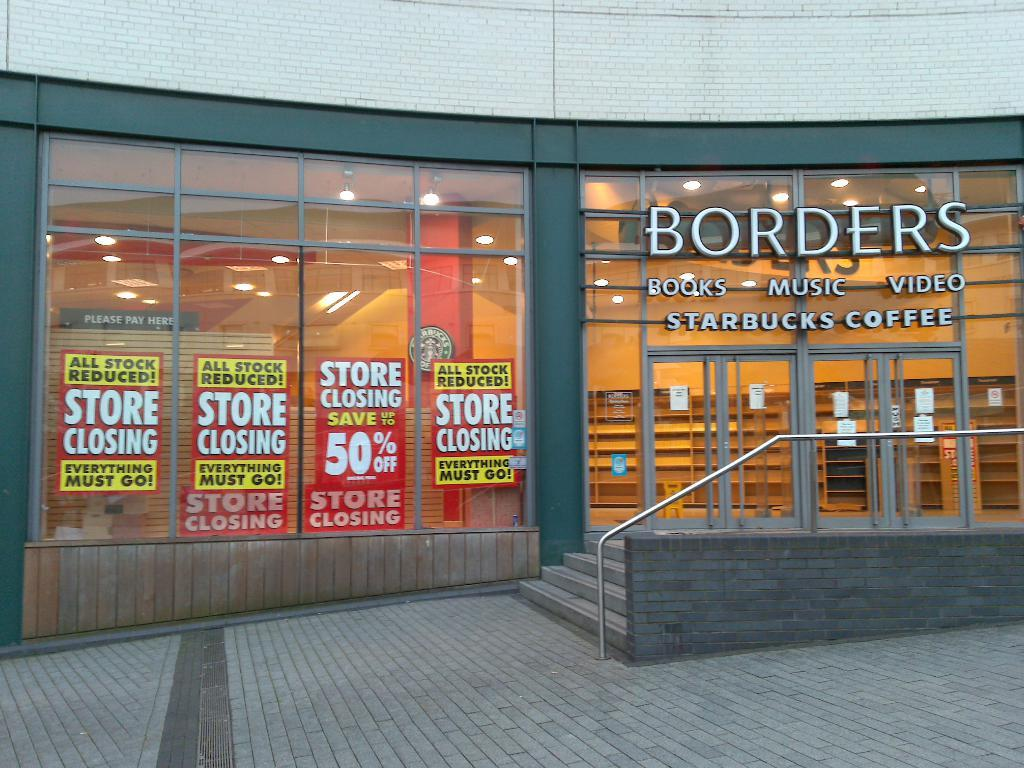What type of structure is visible in the image? There is a building in the image. What can be seen on the glass in the image? There are posters on the glass in the image. What is located on the right side of the image? There is a railing on the right side of the image, and there are also glass doors. What type of flesh can be seen hanging from the railing in the image? There is no flesh present in the image; the railing is a part of the building's structure. 